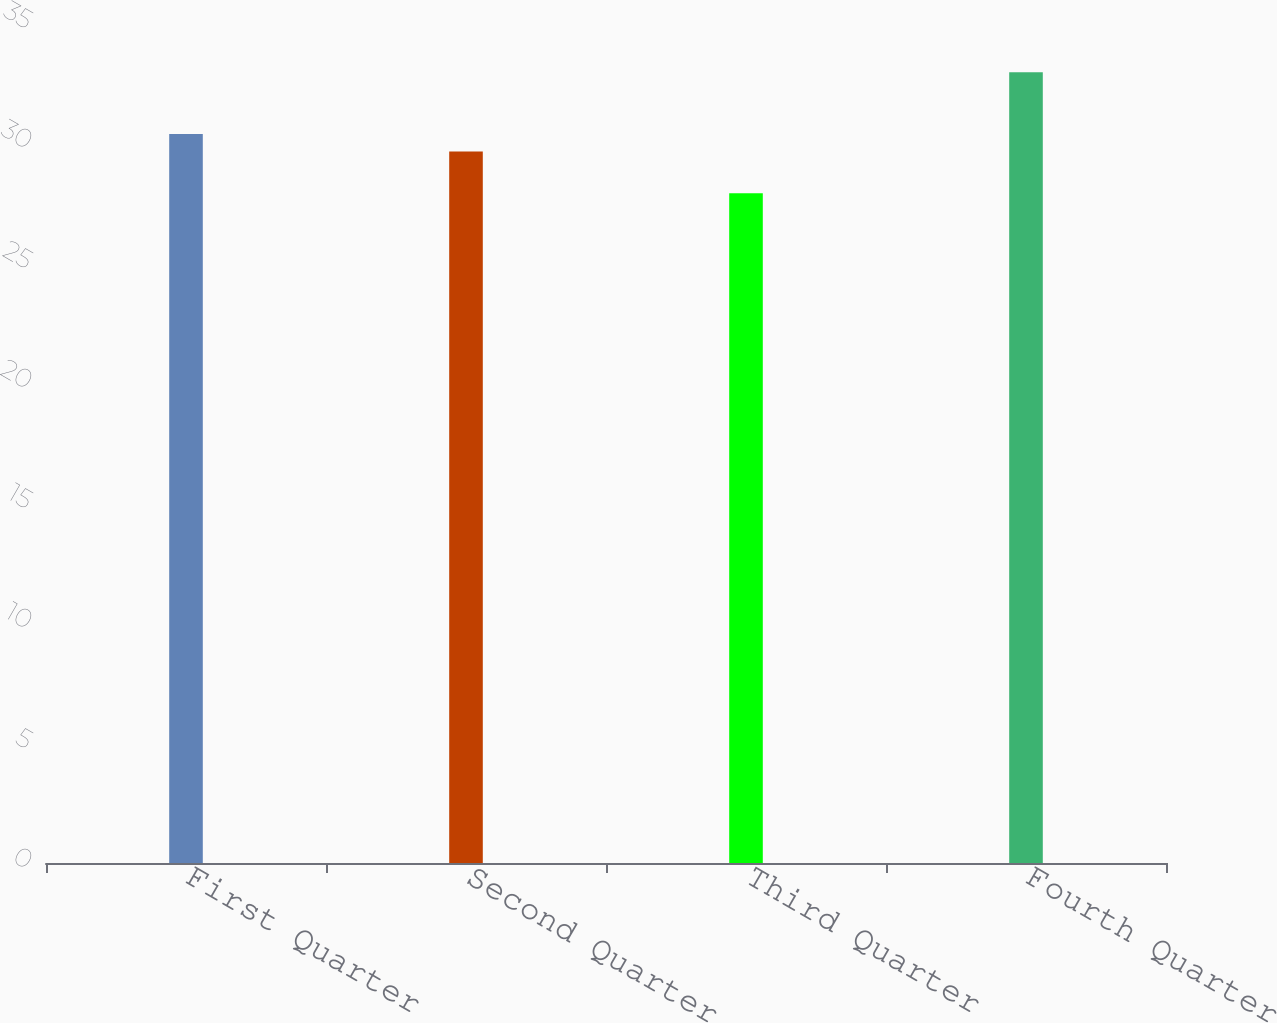Convert chart to OTSL. <chart><loc_0><loc_0><loc_500><loc_500><bar_chart><fcel>First Quarter<fcel>Second Quarter<fcel>Third Quarter<fcel>Fourth Quarter<nl><fcel>30.37<fcel>29.65<fcel>27.91<fcel>32.95<nl></chart> 